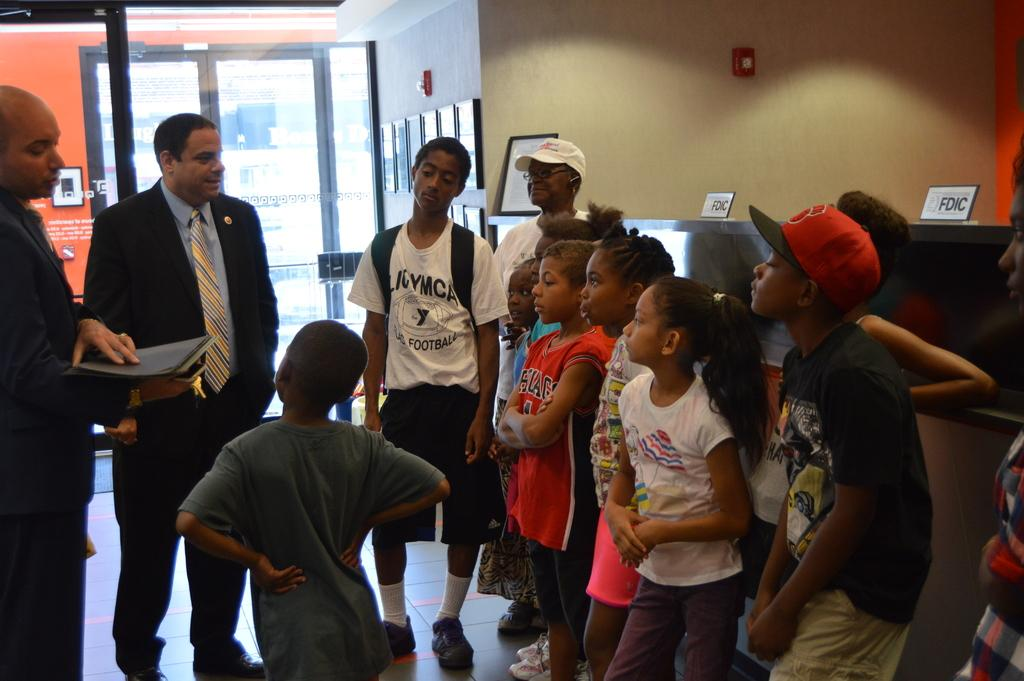What are the people in the image doing? The people in the image are standing. What is the man holding in the image? The man is holding a book. What can be seen in the background of the image? There is a wall and a door in the background of the image. What is placed on the wall in the image? Frames are placed on the wall. What type of sack is being used to carry the bomb in the image? There is no sack or bomb present in the image. How many corks are visible in the image? There are no corks visible in the image. 